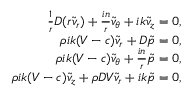<formula> <loc_0><loc_0><loc_500><loc_500>\begin{array} { r } { \frac { 1 } { r } D ( r \tilde { v } _ { r } ) + \frac { i n } { r } \tilde { v } _ { \theta } + i k \tilde { v } _ { z } = 0 , } \\ { \rho i k ( V - c ) \tilde { v } _ { r } + D \tilde { p } = 0 , } \\ { \rho i k ( V - c ) \tilde { v } _ { \theta } + \frac { i n } { r } \tilde { p } = 0 , } \\ { \rho i k ( V - c ) \tilde { v } _ { z } + \rho D V \tilde { v } _ { r } + i k \tilde { p } = 0 , } \end{array}</formula> 